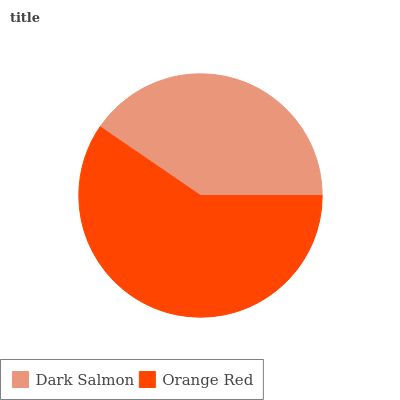Is Dark Salmon the minimum?
Answer yes or no. Yes. Is Orange Red the maximum?
Answer yes or no. Yes. Is Orange Red the minimum?
Answer yes or no. No. Is Orange Red greater than Dark Salmon?
Answer yes or no. Yes. Is Dark Salmon less than Orange Red?
Answer yes or no. Yes. Is Dark Salmon greater than Orange Red?
Answer yes or no. No. Is Orange Red less than Dark Salmon?
Answer yes or no. No. Is Orange Red the high median?
Answer yes or no. Yes. Is Dark Salmon the low median?
Answer yes or no. Yes. Is Dark Salmon the high median?
Answer yes or no. No. Is Orange Red the low median?
Answer yes or no. No. 